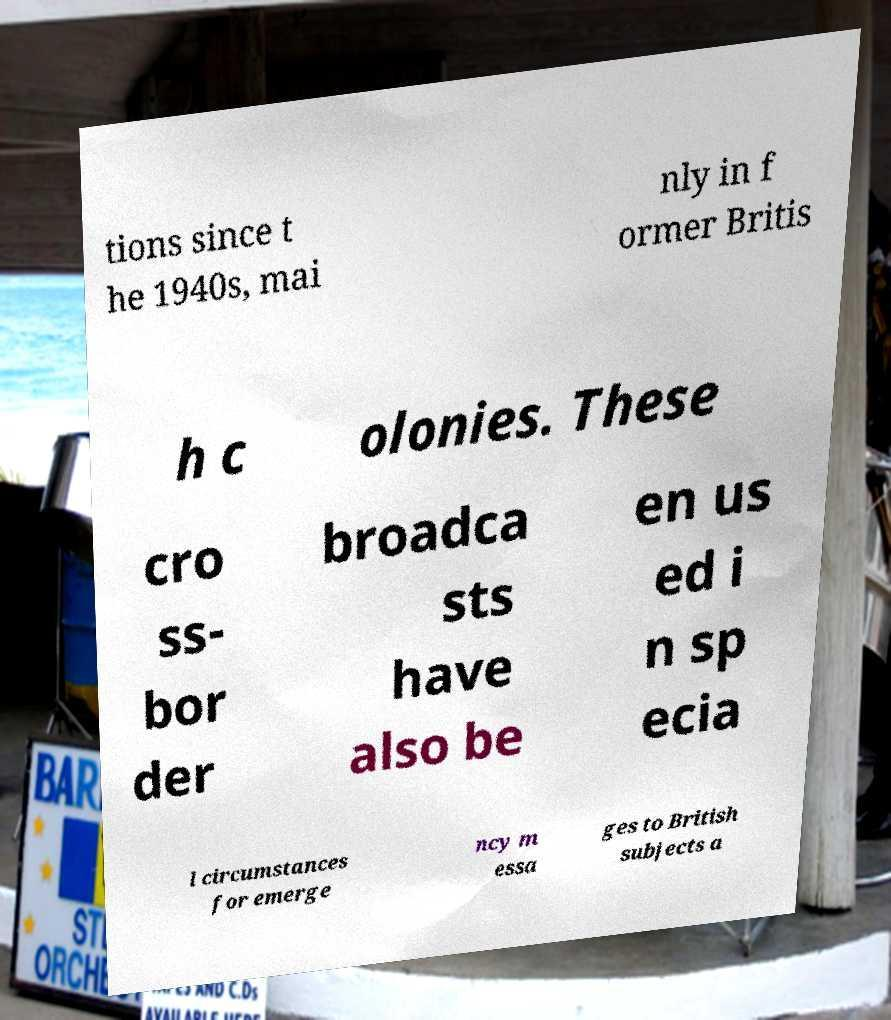Can you accurately transcribe the text from the provided image for me? tions since t he 1940s, mai nly in f ormer Britis h c olonies. These cro ss- bor der broadca sts have also be en us ed i n sp ecia l circumstances for emerge ncy m essa ges to British subjects a 